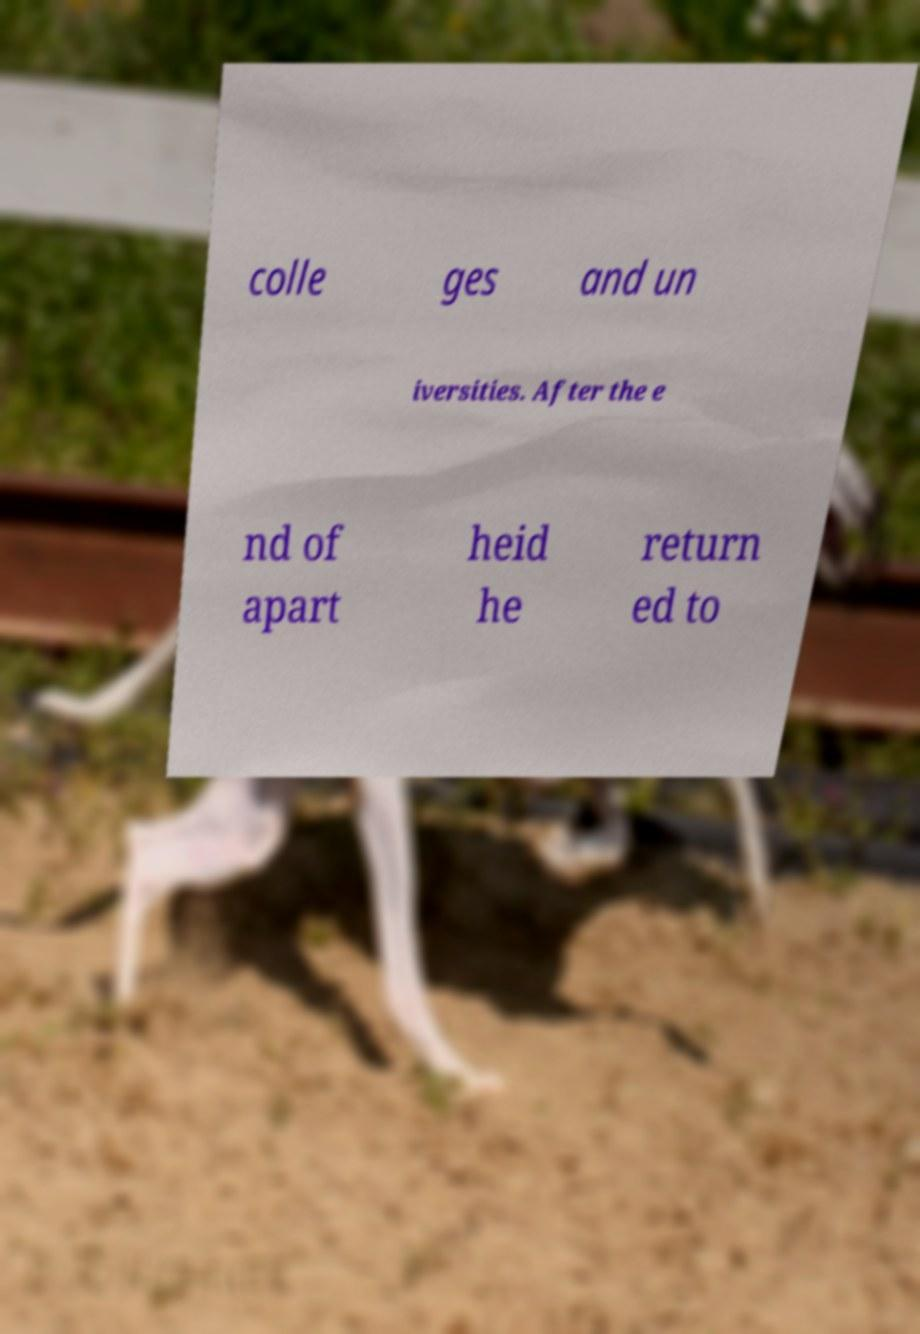Can you accurately transcribe the text from the provided image for me? colle ges and un iversities. After the e nd of apart heid he return ed to 